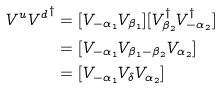<formula> <loc_0><loc_0><loc_500><loc_500>V ^ { u } { V ^ { d } } ^ { \dagger } & = [ V _ { - \alpha _ { 1 } } V _ { \beta _ { 1 } } ] [ V _ { \beta _ { 2 } } ^ { \dagger } V _ { - \alpha _ { 2 } } ^ { \dagger } ] \\ & = [ V _ { - \alpha _ { 1 } } V _ { \beta _ { 1 } - \beta _ { 2 } } V _ { \alpha _ { 2 } } ] \\ & = [ V _ { - \alpha _ { 1 } } V _ { \delta } V _ { \alpha _ { 2 } } ] \\</formula> 